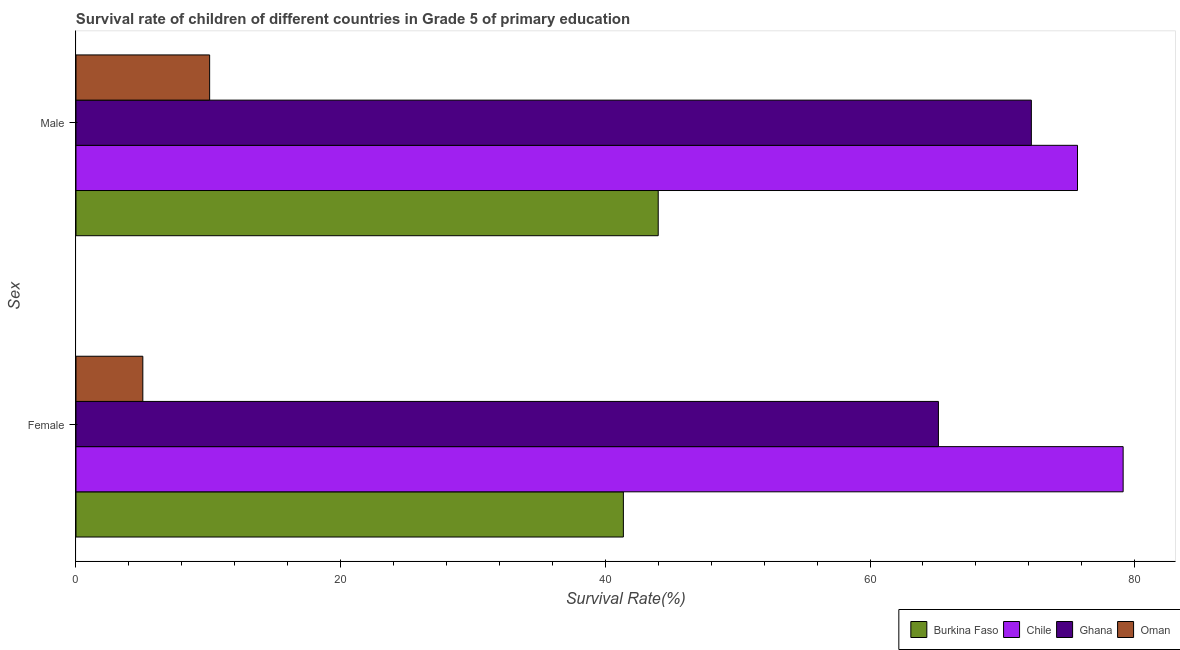How many groups of bars are there?
Keep it short and to the point. 2. Are the number of bars on each tick of the Y-axis equal?
Your answer should be compact. Yes. How many bars are there on the 2nd tick from the top?
Provide a short and direct response. 4. What is the survival rate of female students in primary education in Chile?
Give a very brief answer. 79.12. Across all countries, what is the maximum survival rate of female students in primary education?
Keep it short and to the point. 79.12. Across all countries, what is the minimum survival rate of female students in primary education?
Provide a succinct answer. 5.05. In which country was the survival rate of female students in primary education maximum?
Make the answer very short. Chile. In which country was the survival rate of female students in primary education minimum?
Offer a terse response. Oman. What is the total survival rate of female students in primary education in the graph?
Give a very brief answer. 190.7. What is the difference between the survival rate of male students in primary education in Oman and that in Ghana?
Ensure brevity in your answer.  -62.09. What is the difference between the survival rate of male students in primary education in Burkina Faso and the survival rate of female students in primary education in Chile?
Give a very brief answer. -35.13. What is the average survival rate of female students in primary education per country?
Provide a succinct answer. 47.68. What is the difference between the survival rate of female students in primary education and survival rate of male students in primary education in Oman?
Ensure brevity in your answer.  -5.05. In how many countries, is the survival rate of female students in primary education greater than 8 %?
Make the answer very short. 3. What is the ratio of the survival rate of male students in primary education in Ghana to that in Oman?
Keep it short and to the point. 7.15. Is the survival rate of female students in primary education in Chile less than that in Burkina Faso?
Give a very brief answer. No. In how many countries, is the survival rate of male students in primary education greater than the average survival rate of male students in primary education taken over all countries?
Your answer should be very brief. 2. What does the 4th bar from the top in Female represents?
Offer a terse response. Burkina Faso. Are all the bars in the graph horizontal?
Your response must be concise. Yes. What is the difference between two consecutive major ticks on the X-axis?
Ensure brevity in your answer.  20. What is the title of the graph?
Keep it short and to the point. Survival rate of children of different countries in Grade 5 of primary education. Does "Indonesia" appear as one of the legend labels in the graph?
Provide a succinct answer. No. What is the label or title of the X-axis?
Ensure brevity in your answer.  Survival Rate(%). What is the label or title of the Y-axis?
Provide a succinct answer. Sex. What is the Survival Rate(%) in Burkina Faso in Female?
Your answer should be compact. 41.36. What is the Survival Rate(%) of Chile in Female?
Your answer should be compact. 79.12. What is the Survival Rate(%) in Ghana in Female?
Ensure brevity in your answer.  65.17. What is the Survival Rate(%) in Oman in Female?
Your answer should be compact. 5.05. What is the Survival Rate(%) in Burkina Faso in Male?
Your response must be concise. 43.99. What is the Survival Rate(%) of Chile in Male?
Your answer should be very brief. 75.67. What is the Survival Rate(%) in Ghana in Male?
Ensure brevity in your answer.  72.19. What is the Survival Rate(%) in Oman in Male?
Your answer should be compact. 10.1. Across all Sex, what is the maximum Survival Rate(%) of Burkina Faso?
Ensure brevity in your answer.  43.99. Across all Sex, what is the maximum Survival Rate(%) of Chile?
Your answer should be very brief. 79.12. Across all Sex, what is the maximum Survival Rate(%) in Ghana?
Your answer should be very brief. 72.19. Across all Sex, what is the maximum Survival Rate(%) of Oman?
Make the answer very short. 10.1. Across all Sex, what is the minimum Survival Rate(%) of Burkina Faso?
Offer a very short reply. 41.36. Across all Sex, what is the minimum Survival Rate(%) of Chile?
Offer a terse response. 75.67. Across all Sex, what is the minimum Survival Rate(%) of Ghana?
Give a very brief answer. 65.17. Across all Sex, what is the minimum Survival Rate(%) in Oman?
Provide a succinct answer. 5.05. What is the total Survival Rate(%) of Burkina Faso in the graph?
Your answer should be very brief. 85.35. What is the total Survival Rate(%) of Chile in the graph?
Your response must be concise. 154.8. What is the total Survival Rate(%) of Ghana in the graph?
Give a very brief answer. 137.35. What is the total Survival Rate(%) of Oman in the graph?
Your answer should be compact. 15.15. What is the difference between the Survival Rate(%) of Burkina Faso in Female and that in Male?
Provide a succinct answer. -2.63. What is the difference between the Survival Rate(%) in Chile in Female and that in Male?
Your answer should be very brief. 3.45. What is the difference between the Survival Rate(%) in Ghana in Female and that in Male?
Your answer should be very brief. -7.02. What is the difference between the Survival Rate(%) of Oman in Female and that in Male?
Your answer should be very brief. -5.05. What is the difference between the Survival Rate(%) of Burkina Faso in Female and the Survival Rate(%) of Chile in Male?
Ensure brevity in your answer.  -34.31. What is the difference between the Survival Rate(%) in Burkina Faso in Female and the Survival Rate(%) in Ghana in Male?
Offer a very short reply. -30.83. What is the difference between the Survival Rate(%) of Burkina Faso in Female and the Survival Rate(%) of Oman in Male?
Your answer should be very brief. 31.26. What is the difference between the Survival Rate(%) in Chile in Female and the Survival Rate(%) in Ghana in Male?
Ensure brevity in your answer.  6.93. What is the difference between the Survival Rate(%) in Chile in Female and the Survival Rate(%) in Oman in Male?
Offer a terse response. 69.03. What is the difference between the Survival Rate(%) in Ghana in Female and the Survival Rate(%) in Oman in Male?
Ensure brevity in your answer.  55.07. What is the average Survival Rate(%) in Burkina Faso per Sex?
Provide a short and direct response. 42.68. What is the average Survival Rate(%) in Chile per Sex?
Offer a very short reply. 77.4. What is the average Survival Rate(%) of Ghana per Sex?
Give a very brief answer. 68.68. What is the average Survival Rate(%) in Oman per Sex?
Offer a terse response. 7.57. What is the difference between the Survival Rate(%) in Burkina Faso and Survival Rate(%) in Chile in Female?
Your answer should be very brief. -37.76. What is the difference between the Survival Rate(%) of Burkina Faso and Survival Rate(%) of Ghana in Female?
Give a very brief answer. -23.81. What is the difference between the Survival Rate(%) in Burkina Faso and Survival Rate(%) in Oman in Female?
Offer a very short reply. 36.31. What is the difference between the Survival Rate(%) in Chile and Survival Rate(%) in Ghana in Female?
Your response must be concise. 13.96. What is the difference between the Survival Rate(%) of Chile and Survival Rate(%) of Oman in Female?
Offer a terse response. 74.07. What is the difference between the Survival Rate(%) of Ghana and Survival Rate(%) of Oman in Female?
Ensure brevity in your answer.  60.12. What is the difference between the Survival Rate(%) in Burkina Faso and Survival Rate(%) in Chile in Male?
Your response must be concise. -31.68. What is the difference between the Survival Rate(%) of Burkina Faso and Survival Rate(%) of Ghana in Male?
Your response must be concise. -28.2. What is the difference between the Survival Rate(%) of Burkina Faso and Survival Rate(%) of Oman in Male?
Provide a succinct answer. 33.89. What is the difference between the Survival Rate(%) of Chile and Survival Rate(%) of Ghana in Male?
Your answer should be compact. 3.49. What is the difference between the Survival Rate(%) of Chile and Survival Rate(%) of Oman in Male?
Provide a succinct answer. 65.58. What is the difference between the Survival Rate(%) in Ghana and Survival Rate(%) in Oman in Male?
Provide a short and direct response. 62.09. What is the ratio of the Survival Rate(%) of Burkina Faso in Female to that in Male?
Offer a very short reply. 0.94. What is the ratio of the Survival Rate(%) in Chile in Female to that in Male?
Ensure brevity in your answer.  1.05. What is the ratio of the Survival Rate(%) in Ghana in Female to that in Male?
Your answer should be very brief. 0.9. What is the ratio of the Survival Rate(%) in Oman in Female to that in Male?
Make the answer very short. 0.5. What is the difference between the highest and the second highest Survival Rate(%) of Burkina Faso?
Ensure brevity in your answer.  2.63. What is the difference between the highest and the second highest Survival Rate(%) of Chile?
Your answer should be very brief. 3.45. What is the difference between the highest and the second highest Survival Rate(%) in Ghana?
Offer a very short reply. 7.02. What is the difference between the highest and the second highest Survival Rate(%) in Oman?
Offer a terse response. 5.05. What is the difference between the highest and the lowest Survival Rate(%) of Burkina Faso?
Offer a very short reply. 2.63. What is the difference between the highest and the lowest Survival Rate(%) in Chile?
Your answer should be very brief. 3.45. What is the difference between the highest and the lowest Survival Rate(%) of Ghana?
Make the answer very short. 7.02. What is the difference between the highest and the lowest Survival Rate(%) of Oman?
Provide a short and direct response. 5.05. 